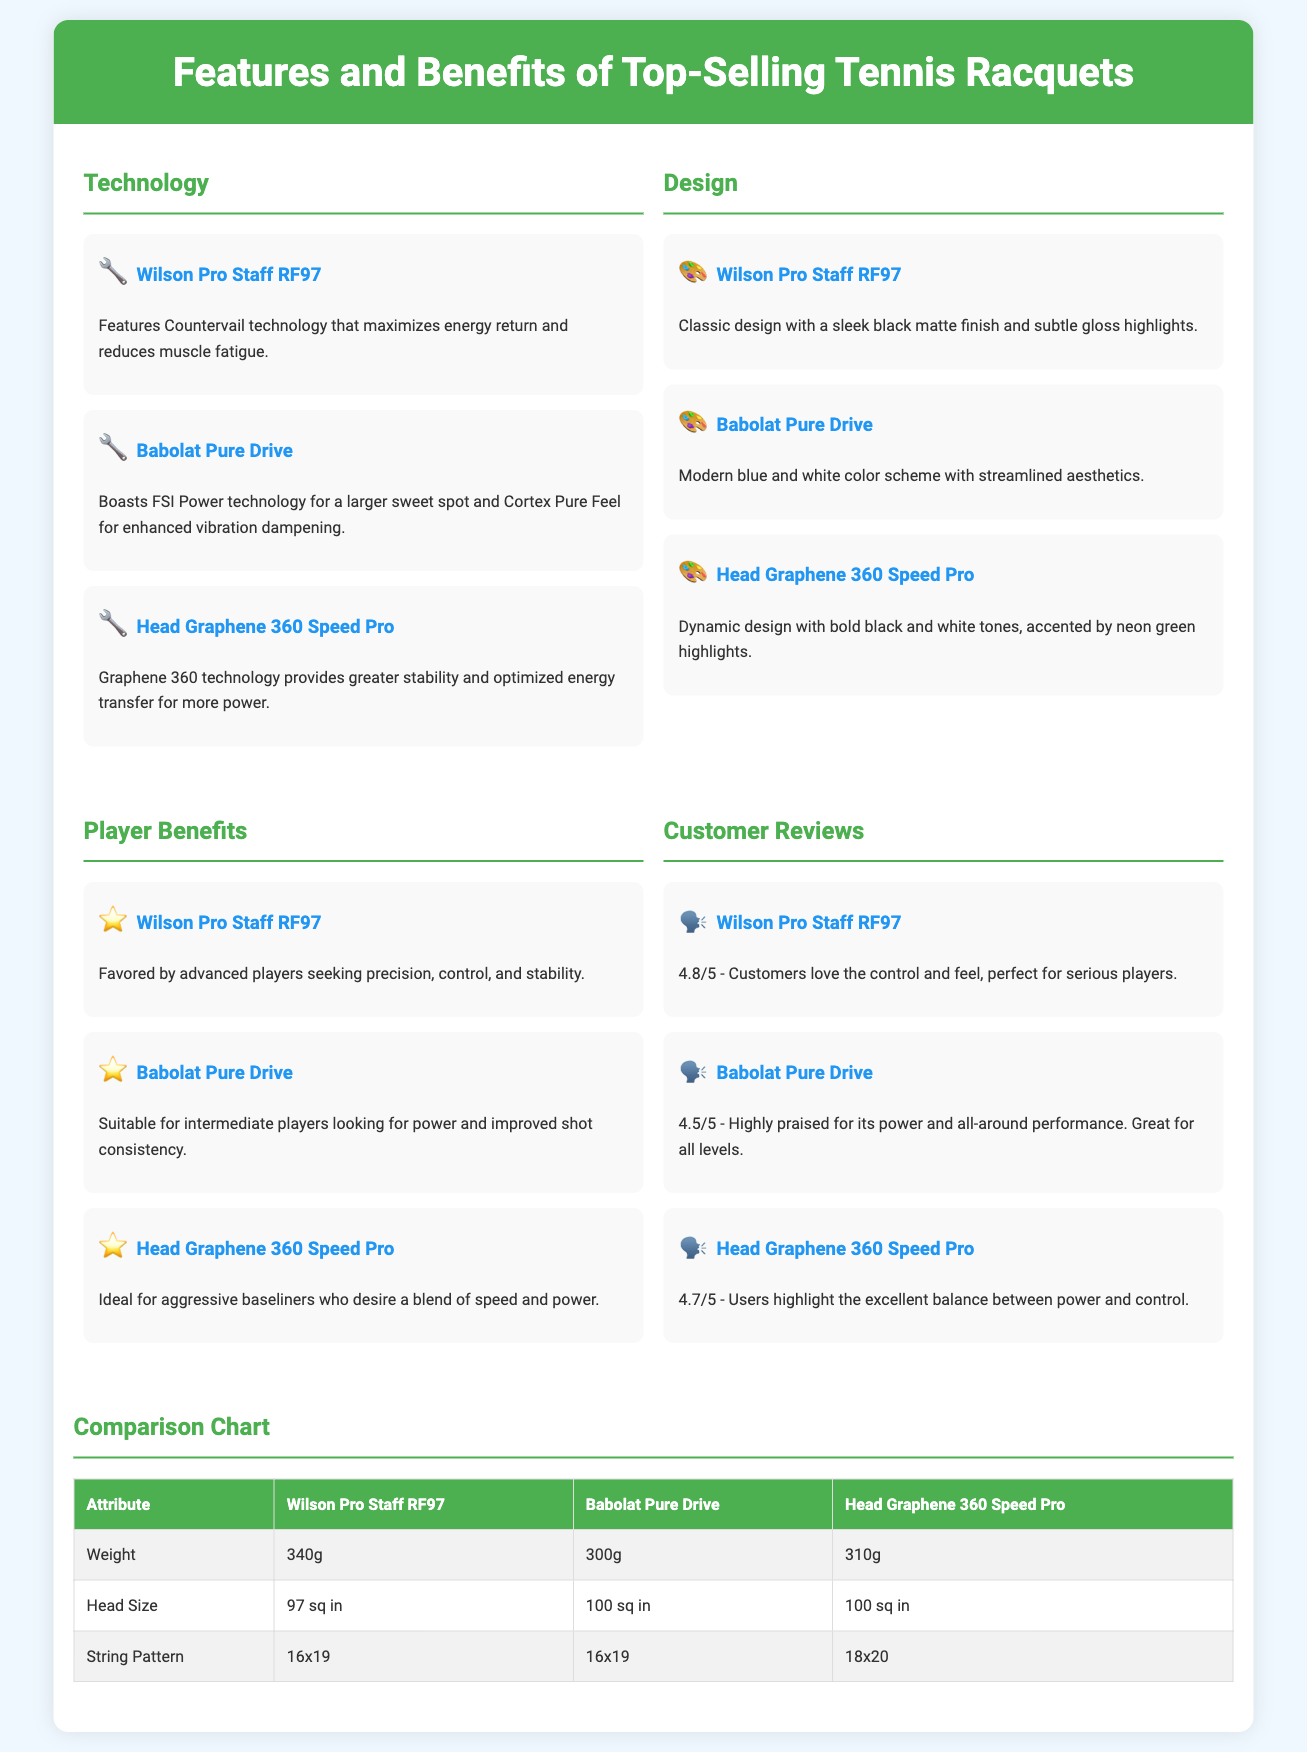What technology does the Wilson Pro Staff RF97 feature? The document states that the Wilson Pro Staff RF97 features Countervail technology.
Answer: Countervail technology What is the weight of the Babolat Pure Drive? According to the comparison chart, the weight of the Babolat Pure Drive is clearly listed.
Answer: 300g Which racquet is ideal for aggressive baseliners? The document specifies that the Head Graphene 360 Speed Pro is ideal for this type of player.
Answer: Head Graphene 360 Speed Pro What is the customer review rating for the Babolat Pure Drive? The customer reviews section details the ratings for each racquet, with the Babolat Pure Drive rating being highlighted.
Answer: 4.5/5 How many squares is the head size of the Wilson Pro Staff RF97? The comparison chart provides specific dimensions for each racquet's head size, which applies to this one as well.
Answer: 97 sq in Which racquet has a string pattern of 18x20? By checking the attributes in the comparison chart, it is evident which racquet holds this specific string pattern.
Answer: Head Graphene 360 Speed Pro Which design color scheme does the Babolat Pure Drive use? The design section gives a clear description of the color scheme, highlighting its modern aesthetic.
Answer: Blue and white What technology does the Head Graphene 360 Speed Pro provide? The specific technology used by the Head Graphene 360 Speed Pro is mentioned under the technology section.
Answer: Graphene 360 technology What is the player benefit of the Wilson Pro Staff RF97? The player benefits section states which kinds of players favor this racquet for its particular qualities.
Answer: Precision, control, and stability 